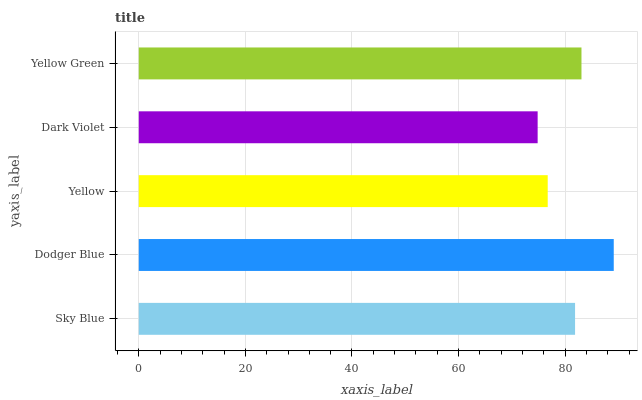Is Dark Violet the minimum?
Answer yes or no. Yes. Is Dodger Blue the maximum?
Answer yes or no. Yes. Is Yellow the minimum?
Answer yes or no. No. Is Yellow the maximum?
Answer yes or no. No. Is Dodger Blue greater than Yellow?
Answer yes or no. Yes. Is Yellow less than Dodger Blue?
Answer yes or no. Yes. Is Yellow greater than Dodger Blue?
Answer yes or no. No. Is Dodger Blue less than Yellow?
Answer yes or no. No. Is Sky Blue the high median?
Answer yes or no. Yes. Is Sky Blue the low median?
Answer yes or no. Yes. Is Dark Violet the high median?
Answer yes or no. No. Is Yellow the low median?
Answer yes or no. No. 